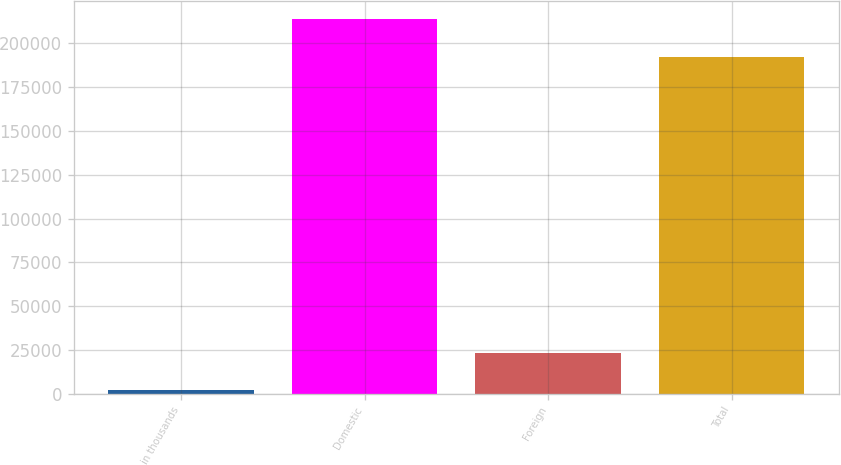Convert chart to OTSL. <chart><loc_0><loc_0><loc_500><loc_500><bar_chart><fcel>in thousands<fcel>Domestic<fcel>Foreign<fcel>Total<nl><fcel>2010<fcel>213598<fcel>23168.8<fcel>192206<nl></chart> 